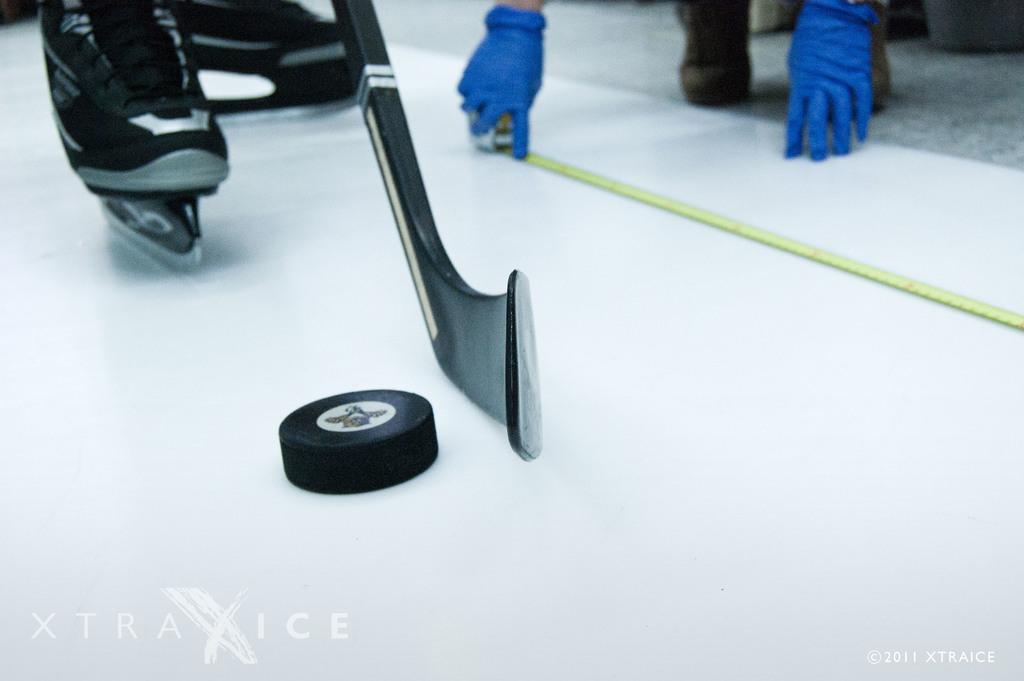Could you give a brief overview of what you see in this image? In the image there is an object, behind the object there are two legs and under the shoe there are skates and in the background there are hands and legs of a person. 